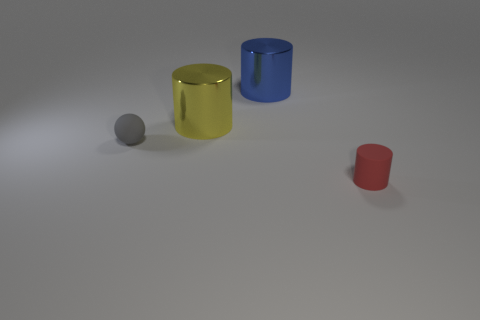Can you describe the shapes of the objects besides the tiny ball? Certainly! There are three objects in addition to the tiny ball, each with distinct shapes: a yellow cylinder, a blue cylinder with an open top, resembling a cup or container, and a small red cylinder that looks like a truncated cone or a cup. 